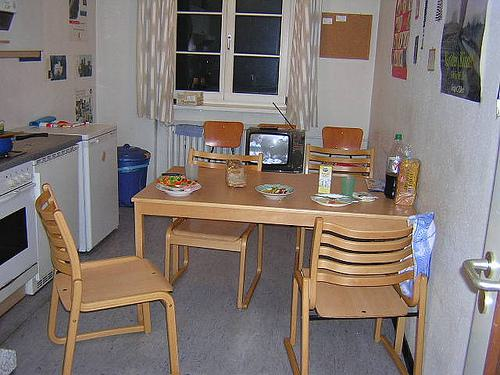How many chairs are there in the image? 5 